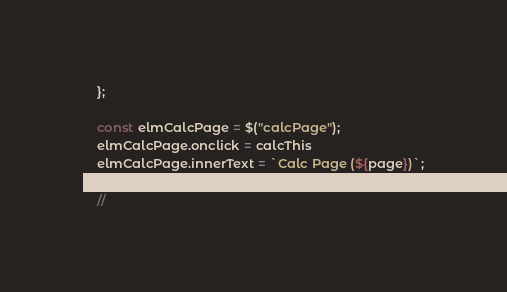<code> <loc_0><loc_0><loc_500><loc_500><_JavaScript_>
    };

    const elmCalcPage = $("calcPage");
    elmCalcPage.onclick = calcThis
    elmCalcPage.innerText = `Calc Page (${page})`;

    //</code> 